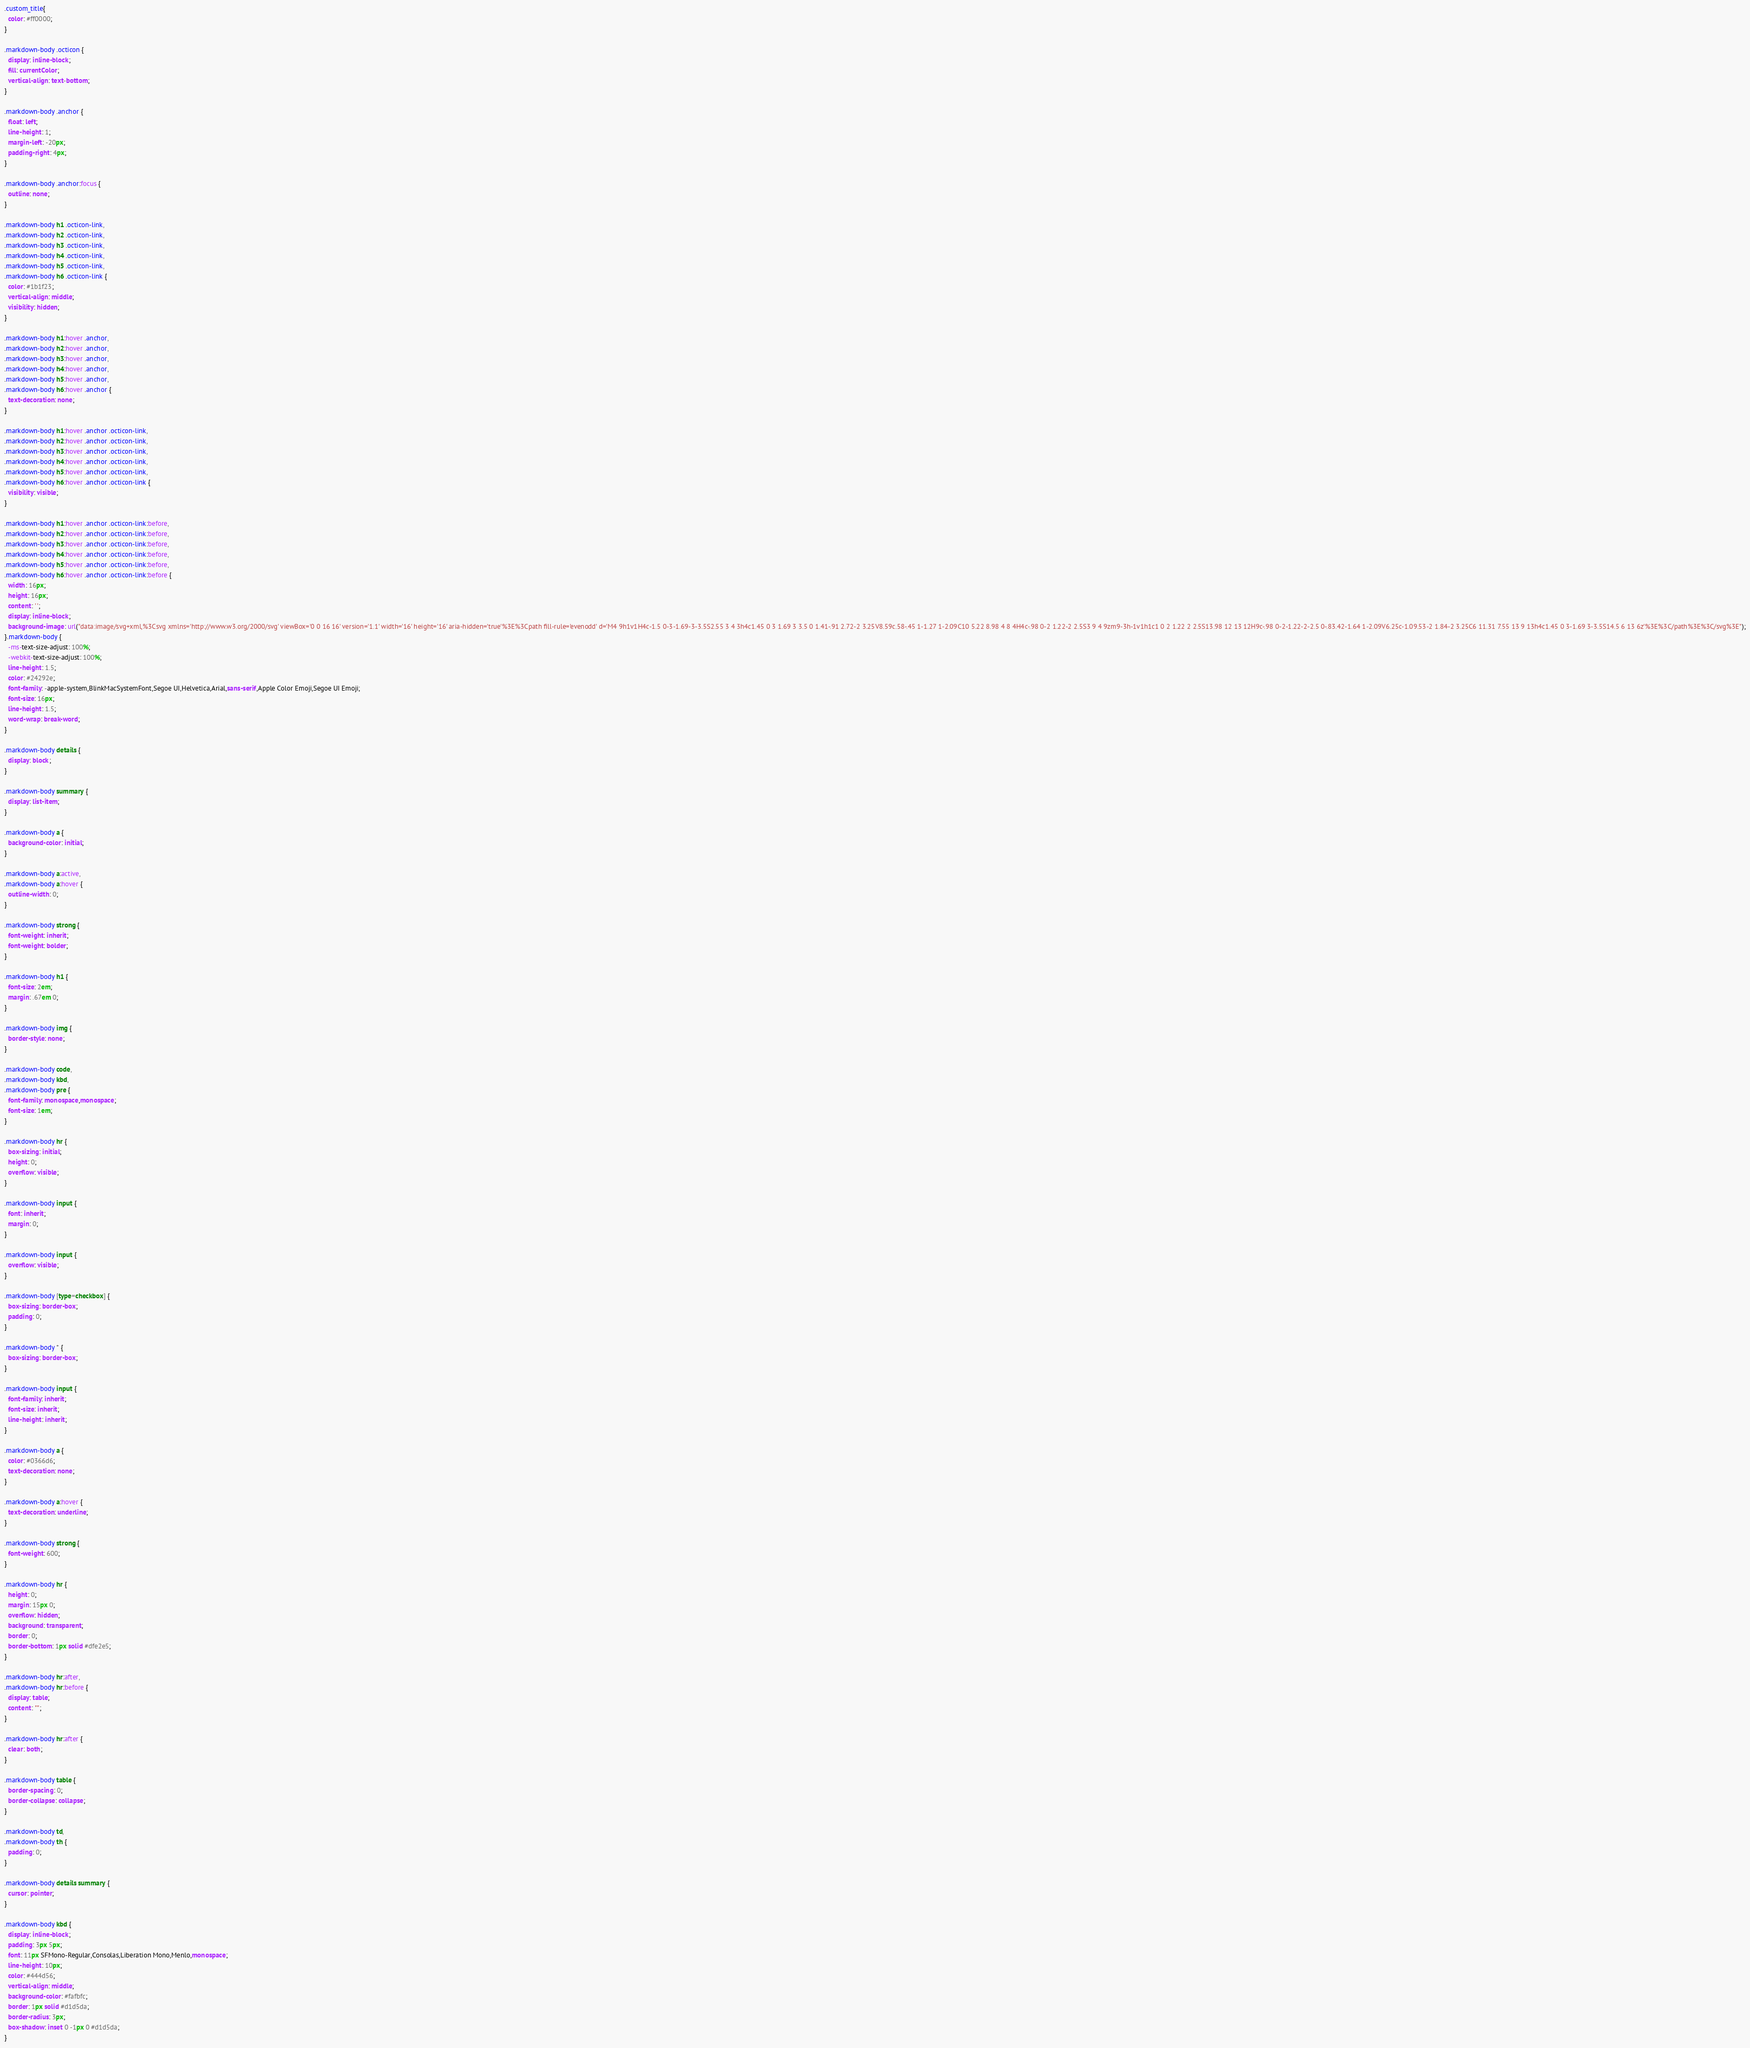Convert code to text. <code><loc_0><loc_0><loc_500><loc_500><_CSS_>.custom_title{
  color: #ff0000;
}

.markdown-body .octicon {
  display: inline-block;
  fill: currentColor;
  vertical-align: text-bottom;
}

.markdown-body .anchor {
  float: left;
  line-height: 1;
  margin-left: -20px;
  padding-right: 4px;
}

.markdown-body .anchor:focus {
  outline: none;
}

.markdown-body h1 .octicon-link,
.markdown-body h2 .octicon-link,
.markdown-body h3 .octicon-link,
.markdown-body h4 .octicon-link,
.markdown-body h5 .octicon-link,
.markdown-body h6 .octicon-link {
  color: #1b1f23;
  vertical-align: middle;
  visibility: hidden;
}

.markdown-body h1:hover .anchor,
.markdown-body h2:hover .anchor,
.markdown-body h3:hover .anchor,
.markdown-body h4:hover .anchor,
.markdown-body h5:hover .anchor,
.markdown-body h6:hover .anchor {
  text-decoration: none;
}

.markdown-body h1:hover .anchor .octicon-link,
.markdown-body h2:hover .anchor .octicon-link,
.markdown-body h3:hover .anchor .octicon-link,
.markdown-body h4:hover .anchor .octicon-link,
.markdown-body h5:hover .anchor .octicon-link,
.markdown-body h6:hover .anchor .octicon-link {
  visibility: visible;
}

.markdown-body h1:hover .anchor .octicon-link:before,
.markdown-body h2:hover .anchor .octicon-link:before,
.markdown-body h3:hover .anchor .octicon-link:before,
.markdown-body h4:hover .anchor .octicon-link:before,
.markdown-body h5:hover .anchor .octicon-link:before,
.markdown-body h6:hover .anchor .octicon-link:before {
  width: 16px;
  height: 16px;
  content: ' ';
  display: inline-block;
  background-image: url("data:image/svg+xml,%3Csvg xmlns='http://www.w3.org/2000/svg' viewBox='0 0 16 16' version='1.1' width='16' height='16' aria-hidden='true'%3E%3Cpath fill-rule='evenodd' d='M4 9h1v1H4c-1.5 0-3-1.69-3-3.5S2.55 3 4 3h4c1.45 0 3 1.69 3 3.5 0 1.41-.91 2.72-2 3.25V8.59c.58-.45 1-1.27 1-2.09C10 5.22 8.98 4 8 4H4c-.98 0-2 1.22-2 2.5S3 9 4 9zm9-3h-1v1h1c1 0 2 1.22 2 2.5S13.98 12 13 12H9c-.98 0-2-1.22-2-2.5 0-.83.42-1.64 1-2.09V6.25c-1.09.53-2 1.84-2 3.25C6 11.31 7.55 13 9 13h4c1.45 0 3-1.69 3-3.5S14.5 6 13 6z'%3E%3C/path%3E%3C/svg%3E");
}.markdown-body {
  -ms-text-size-adjust: 100%;
  -webkit-text-size-adjust: 100%;
  line-height: 1.5;
  color: #24292e;
  font-family: -apple-system,BlinkMacSystemFont,Segoe UI,Helvetica,Arial,sans-serif,Apple Color Emoji,Segoe UI Emoji;
  font-size: 16px;
  line-height: 1.5;
  word-wrap: break-word;
}

.markdown-body details {
  display: block;
}

.markdown-body summary {
  display: list-item;
}

.markdown-body a {
  background-color: initial;
}

.markdown-body a:active,
.markdown-body a:hover {
  outline-width: 0;
}

.markdown-body strong {
  font-weight: inherit;
  font-weight: bolder;
}

.markdown-body h1 {
  font-size: 2em;
  margin: .67em 0;
}

.markdown-body img {
  border-style: none;
}

.markdown-body code,
.markdown-body kbd,
.markdown-body pre {
  font-family: monospace,monospace;
  font-size: 1em;
}

.markdown-body hr {
  box-sizing: initial;
  height: 0;
  overflow: visible;
}

.markdown-body input {
  font: inherit;
  margin: 0;
}

.markdown-body input {
  overflow: visible;
}

.markdown-body [type=checkbox] {
  box-sizing: border-box;
  padding: 0;
}

.markdown-body * {
  box-sizing: border-box;
}

.markdown-body input {
  font-family: inherit;
  font-size: inherit;
  line-height: inherit;
}

.markdown-body a {
  color: #0366d6;
  text-decoration: none;
}

.markdown-body a:hover {
  text-decoration: underline;
}

.markdown-body strong {
  font-weight: 600;
}

.markdown-body hr {
  height: 0;
  margin: 15px 0;
  overflow: hidden;
  background: transparent;
  border: 0;
  border-bottom: 1px solid #dfe2e5;
}

.markdown-body hr:after,
.markdown-body hr:before {
  display: table;
  content: "";
}

.markdown-body hr:after {
  clear: both;
}

.markdown-body table {
  border-spacing: 0;
  border-collapse: collapse;
}

.markdown-body td,
.markdown-body th {
  padding: 0;
}

.markdown-body details summary {
  cursor: pointer;
}

.markdown-body kbd {
  display: inline-block;
  padding: 3px 5px;
  font: 11px SFMono-Regular,Consolas,Liberation Mono,Menlo,monospace;
  line-height: 10px;
  color: #444d56;
  vertical-align: middle;
  background-color: #fafbfc;
  border: 1px solid #d1d5da;
  border-radius: 3px;
  box-shadow: inset 0 -1px 0 #d1d5da;
}
</code> 